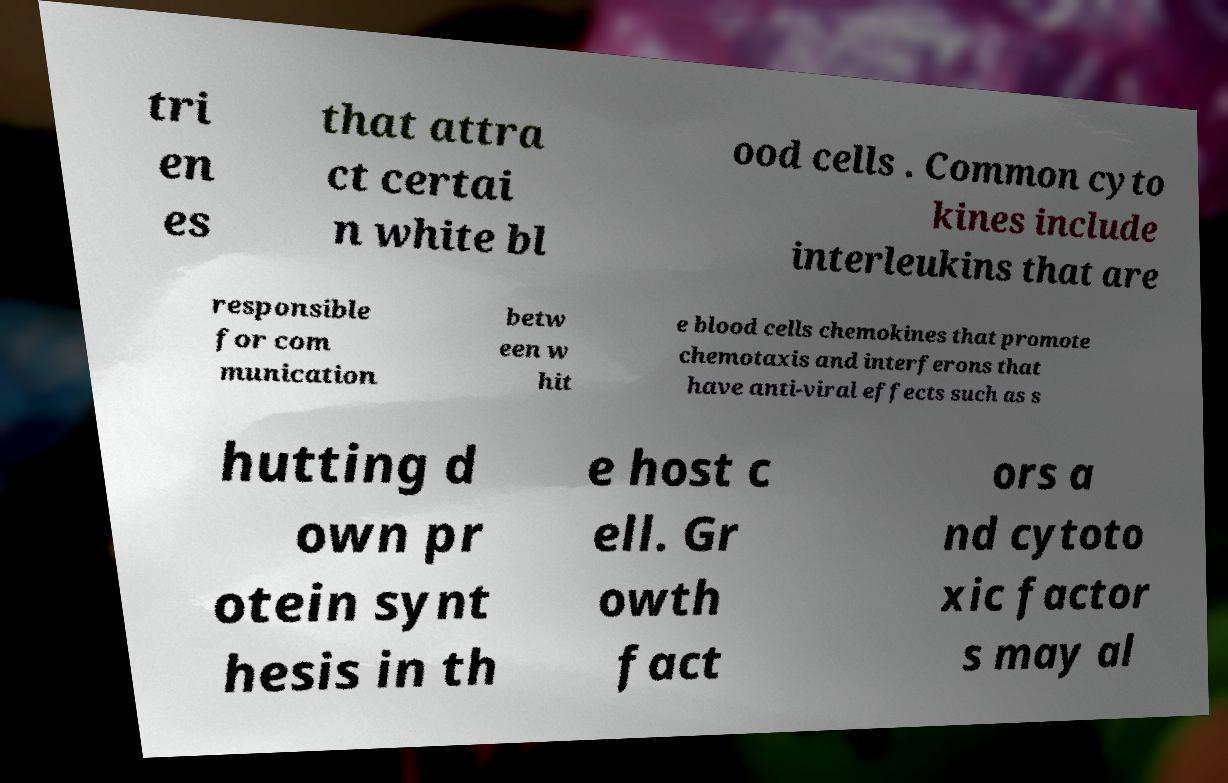Please read and relay the text visible in this image. What does it say? tri en es that attra ct certai n white bl ood cells . Common cyto kines include interleukins that are responsible for com munication betw een w hit e blood cells chemokines that promote chemotaxis and interferons that have anti-viral effects such as s hutting d own pr otein synt hesis in th e host c ell. Gr owth fact ors a nd cytoto xic factor s may al 